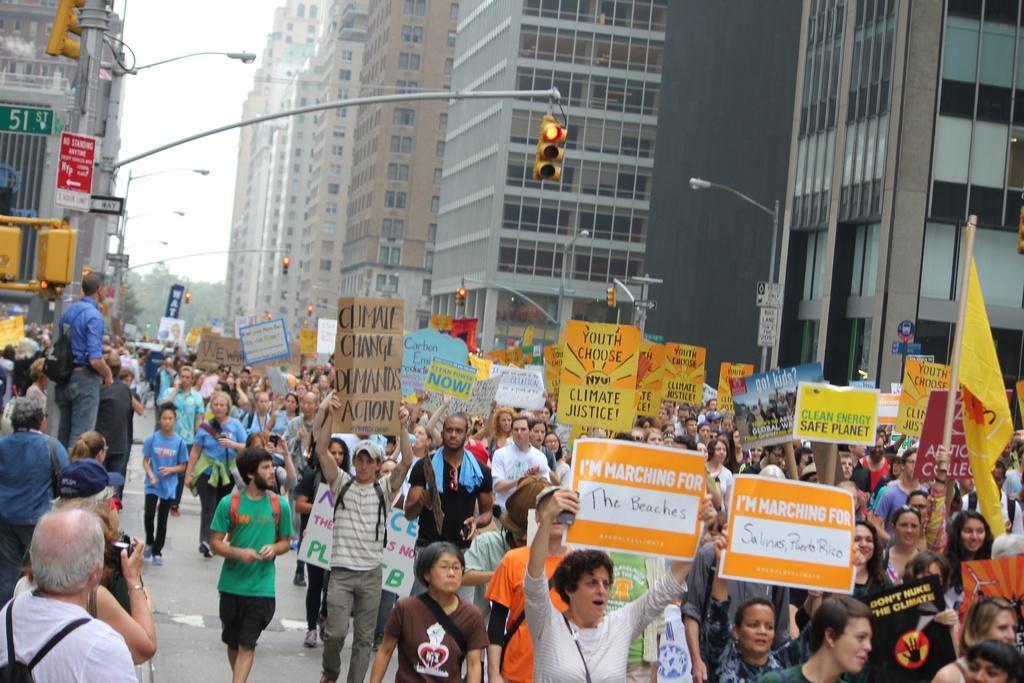Please provide a concise description of this image. In this image we can see some group of persons standing and walking through the road, holding some boards in their hands, sloganeering and in the background of the image there are some traffic signals, street light poles, buildings and trees and top of the image there is clear sky. 